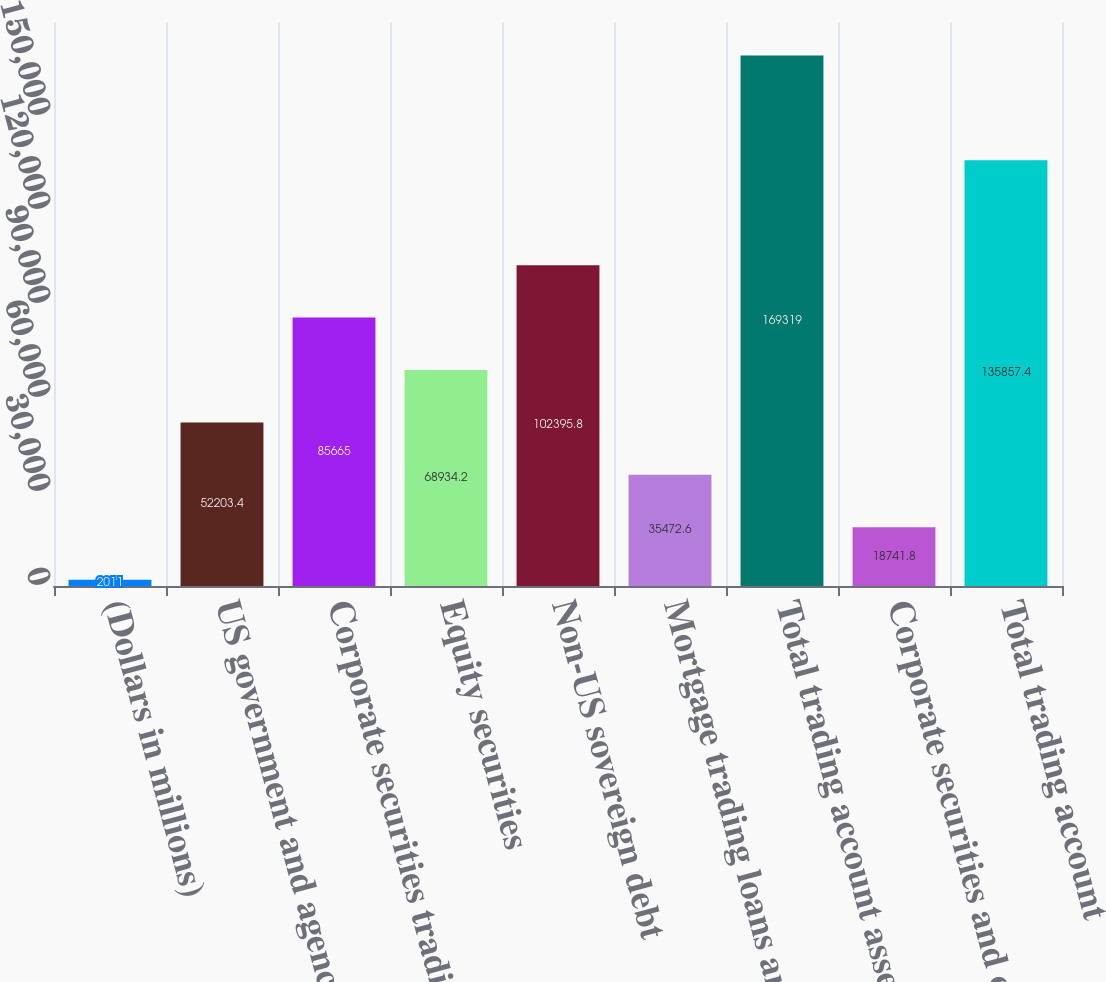Convert chart to OTSL. <chart><loc_0><loc_0><loc_500><loc_500><bar_chart><fcel>(Dollars in millions)<fcel>US government and agency<fcel>Corporate securities trading<fcel>Equity securities<fcel>Non-US sovereign debt<fcel>Mortgage trading loans and<fcel>Total trading account assets<fcel>Corporate securities and other<fcel>Total trading account<nl><fcel>2011<fcel>52203.4<fcel>85665<fcel>68934.2<fcel>102396<fcel>35472.6<fcel>169319<fcel>18741.8<fcel>135857<nl></chart> 